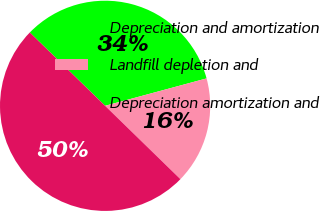Convert chart to OTSL. <chart><loc_0><loc_0><loc_500><loc_500><pie_chart><fcel>Depreciation and amortization<fcel>Landfill depletion and<fcel>Depreciation amortization and<nl><fcel>33.51%<fcel>16.49%<fcel>50.0%<nl></chart> 